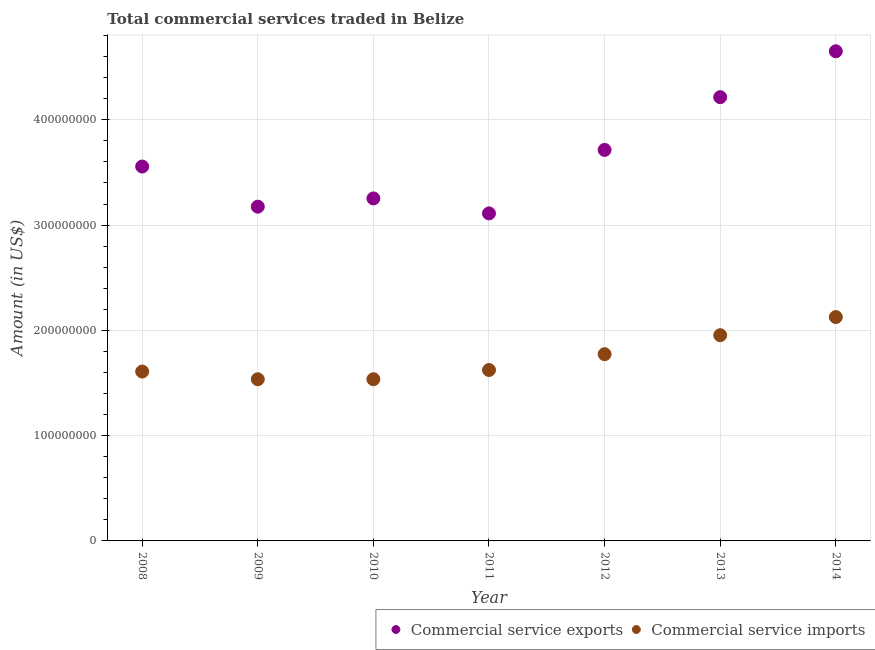How many different coloured dotlines are there?
Make the answer very short. 2. What is the amount of commercial service imports in 2010?
Make the answer very short. 1.54e+08. Across all years, what is the maximum amount of commercial service imports?
Your response must be concise. 2.13e+08. Across all years, what is the minimum amount of commercial service imports?
Make the answer very short. 1.54e+08. In which year was the amount of commercial service imports maximum?
Keep it short and to the point. 2014. What is the total amount of commercial service exports in the graph?
Make the answer very short. 2.57e+09. What is the difference between the amount of commercial service imports in 2008 and that in 2014?
Provide a succinct answer. -5.17e+07. What is the difference between the amount of commercial service exports in 2010 and the amount of commercial service imports in 2014?
Your answer should be very brief. 1.13e+08. What is the average amount of commercial service exports per year?
Make the answer very short. 3.67e+08. In the year 2011, what is the difference between the amount of commercial service exports and amount of commercial service imports?
Keep it short and to the point. 1.49e+08. In how many years, is the amount of commercial service imports greater than 280000000 US$?
Provide a succinct answer. 0. What is the ratio of the amount of commercial service imports in 2010 to that in 2014?
Your answer should be compact. 0.72. Is the amount of commercial service imports in 2008 less than that in 2014?
Ensure brevity in your answer.  Yes. What is the difference between the highest and the second highest amount of commercial service exports?
Provide a succinct answer. 4.36e+07. What is the difference between the highest and the lowest amount of commercial service imports?
Offer a terse response. 5.91e+07. In how many years, is the amount of commercial service imports greater than the average amount of commercial service imports taken over all years?
Offer a terse response. 3. Is the amount of commercial service imports strictly less than the amount of commercial service exports over the years?
Your answer should be compact. Yes. How many dotlines are there?
Ensure brevity in your answer.  2. How many years are there in the graph?
Provide a succinct answer. 7. What is the difference between two consecutive major ticks on the Y-axis?
Your answer should be very brief. 1.00e+08. Does the graph contain any zero values?
Ensure brevity in your answer.  No. Does the graph contain grids?
Your response must be concise. Yes. What is the title of the graph?
Make the answer very short. Total commercial services traded in Belize. Does "Current US$" appear as one of the legend labels in the graph?
Provide a short and direct response. No. What is the label or title of the X-axis?
Give a very brief answer. Year. What is the label or title of the Y-axis?
Offer a very short reply. Amount (in US$). What is the Amount (in US$) of Commercial service exports in 2008?
Offer a terse response. 3.56e+08. What is the Amount (in US$) in Commercial service imports in 2008?
Offer a terse response. 1.61e+08. What is the Amount (in US$) of Commercial service exports in 2009?
Give a very brief answer. 3.17e+08. What is the Amount (in US$) in Commercial service imports in 2009?
Give a very brief answer. 1.54e+08. What is the Amount (in US$) in Commercial service exports in 2010?
Your answer should be compact. 3.25e+08. What is the Amount (in US$) of Commercial service imports in 2010?
Your response must be concise. 1.54e+08. What is the Amount (in US$) in Commercial service exports in 2011?
Your answer should be very brief. 3.11e+08. What is the Amount (in US$) in Commercial service imports in 2011?
Give a very brief answer. 1.62e+08. What is the Amount (in US$) in Commercial service exports in 2012?
Your answer should be very brief. 3.71e+08. What is the Amount (in US$) of Commercial service imports in 2012?
Your answer should be very brief. 1.77e+08. What is the Amount (in US$) in Commercial service exports in 2013?
Your response must be concise. 4.21e+08. What is the Amount (in US$) of Commercial service imports in 2013?
Your answer should be compact. 1.95e+08. What is the Amount (in US$) of Commercial service exports in 2014?
Offer a very short reply. 4.65e+08. What is the Amount (in US$) of Commercial service imports in 2014?
Keep it short and to the point. 2.13e+08. Across all years, what is the maximum Amount (in US$) of Commercial service exports?
Your answer should be very brief. 4.65e+08. Across all years, what is the maximum Amount (in US$) of Commercial service imports?
Offer a very short reply. 2.13e+08. Across all years, what is the minimum Amount (in US$) of Commercial service exports?
Offer a terse response. 3.11e+08. Across all years, what is the minimum Amount (in US$) in Commercial service imports?
Provide a short and direct response. 1.54e+08. What is the total Amount (in US$) of Commercial service exports in the graph?
Keep it short and to the point. 2.57e+09. What is the total Amount (in US$) in Commercial service imports in the graph?
Your answer should be compact. 1.22e+09. What is the difference between the Amount (in US$) of Commercial service exports in 2008 and that in 2009?
Provide a succinct answer. 3.81e+07. What is the difference between the Amount (in US$) of Commercial service imports in 2008 and that in 2009?
Ensure brevity in your answer.  7.33e+06. What is the difference between the Amount (in US$) of Commercial service exports in 2008 and that in 2010?
Your answer should be compact. 3.03e+07. What is the difference between the Amount (in US$) in Commercial service imports in 2008 and that in 2010?
Give a very brief answer. 7.29e+06. What is the difference between the Amount (in US$) of Commercial service exports in 2008 and that in 2011?
Provide a short and direct response. 4.45e+07. What is the difference between the Amount (in US$) in Commercial service imports in 2008 and that in 2011?
Keep it short and to the point. -1.48e+06. What is the difference between the Amount (in US$) in Commercial service exports in 2008 and that in 2012?
Ensure brevity in your answer.  -1.58e+07. What is the difference between the Amount (in US$) in Commercial service imports in 2008 and that in 2012?
Provide a succinct answer. -1.65e+07. What is the difference between the Amount (in US$) in Commercial service exports in 2008 and that in 2013?
Give a very brief answer. -6.59e+07. What is the difference between the Amount (in US$) of Commercial service imports in 2008 and that in 2013?
Offer a terse response. -3.45e+07. What is the difference between the Amount (in US$) of Commercial service exports in 2008 and that in 2014?
Provide a short and direct response. -1.09e+08. What is the difference between the Amount (in US$) in Commercial service imports in 2008 and that in 2014?
Your response must be concise. -5.17e+07. What is the difference between the Amount (in US$) in Commercial service exports in 2009 and that in 2010?
Provide a short and direct response. -7.86e+06. What is the difference between the Amount (in US$) in Commercial service imports in 2009 and that in 2010?
Your answer should be very brief. -4.16e+04. What is the difference between the Amount (in US$) of Commercial service exports in 2009 and that in 2011?
Offer a terse response. 6.41e+06. What is the difference between the Amount (in US$) of Commercial service imports in 2009 and that in 2011?
Make the answer very short. -8.80e+06. What is the difference between the Amount (in US$) of Commercial service exports in 2009 and that in 2012?
Make the answer very short. -5.39e+07. What is the difference between the Amount (in US$) in Commercial service imports in 2009 and that in 2012?
Keep it short and to the point. -2.38e+07. What is the difference between the Amount (in US$) in Commercial service exports in 2009 and that in 2013?
Keep it short and to the point. -1.04e+08. What is the difference between the Amount (in US$) of Commercial service imports in 2009 and that in 2013?
Offer a terse response. -4.18e+07. What is the difference between the Amount (in US$) of Commercial service exports in 2009 and that in 2014?
Provide a succinct answer. -1.48e+08. What is the difference between the Amount (in US$) in Commercial service imports in 2009 and that in 2014?
Your answer should be very brief. -5.91e+07. What is the difference between the Amount (in US$) in Commercial service exports in 2010 and that in 2011?
Keep it short and to the point. 1.43e+07. What is the difference between the Amount (in US$) of Commercial service imports in 2010 and that in 2011?
Offer a terse response. -8.76e+06. What is the difference between the Amount (in US$) of Commercial service exports in 2010 and that in 2012?
Make the answer very short. -4.61e+07. What is the difference between the Amount (in US$) in Commercial service imports in 2010 and that in 2012?
Offer a terse response. -2.38e+07. What is the difference between the Amount (in US$) of Commercial service exports in 2010 and that in 2013?
Provide a short and direct response. -9.62e+07. What is the difference between the Amount (in US$) in Commercial service imports in 2010 and that in 2013?
Keep it short and to the point. -4.18e+07. What is the difference between the Amount (in US$) of Commercial service exports in 2010 and that in 2014?
Offer a very short reply. -1.40e+08. What is the difference between the Amount (in US$) of Commercial service imports in 2010 and that in 2014?
Make the answer very short. -5.90e+07. What is the difference between the Amount (in US$) in Commercial service exports in 2011 and that in 2012?
Make the answer very short. -6.03e+07. What is the difference between the Amount (in US$) in Commercial service imports in 2011 and that in 2012?
Keep it short and to the point. -1.50e+07. What is the difference between the Amount (in US$) of Commercial service exports in 2011 and that in 2013?
Provide a short and direct response. -1.10e+08. What is the difference between the Amount (in US$) of Commercial service imports in 2011 and that in 2013?
Offer a very short reply. -3.30e+07. What is the difference between the Amount (in US$) of Commercial service exports in 2011 and that in 2014?
Your answer should be compact. -1.54e+08. What is the difference between the Amount (in US$) in Commercial service imports in 2011 and that in 2014?
Make the answer very short. -5.03e+07. What is the difference between the Amount (in US$) of Commercial service exports in 2012 and that in 2013?
Make the answer very short. -5.01e+07. What is the difference between the Amount (in US$) of Commercial service imports in 2012 and that in 2013?
Offer a very short reply. -1.80e+07. What is the difference between the Amount (in US$) of Commercial service exports in 2012 and that in 2014?
Your answer should be compact. -9.37e+07. What is the difference between the Amount (in US$) in Commercial service imports in 2012 and that in 2014?
Offer a terse response. -3.53e+07. What is the difference between the Amount (in US$) in Commercial service exports in 2013 and that in 2014?
Give a very brief answer. -4.36e+07. What is the difference between the Amount (in US$) of Commercial service imports in 2013 and that in 2014?
Provide a short and direct response. -1.72e+07. What is the difference between the Amount (in US$) of Commercial service exports in 2008 and the Amount (in US$) of Commercial service imports in 2009?
Provide a succinct answer. 2.02e+08. What is the difference between the Amount (in US$) in Commercial service exports in 2008 and the Amount (in US$) in Commercial service imports in 2010?
Provide a short and direct response. 2.02e+08. What is the difference between the Amount (in US$) of Commercial service exports in 2008 and the Amount (in US$) of Commercial service imports in 2011?
Your response must be concise. 1.93e+08. What is the difference between the Amount (in US$) of Commercial service exports in 2008 and the Amount (in US$) of Commercial service imports in 2012?
Provide a short and direct response. 1.78e+08. What is the difference between the Amount (in US$) of Commercial service exports in 2008 and the Amount (in US$) of Commercial service imports in 2013?
Your answer should be very brief. 1.60e+08. What is the difference between the Amount (in US$) in Commercial service exports in 2008 and the Amount (in US$) in Commercial service imports in 2014?
Provide a succinct answer. 1.43e+08. What is the difference between the Amount (in US$) in Commercial service exports in 2009 and the Amount (in US$) in Commercial service imports in 2010?
Offer a terse response. 1.64e+08. What is the difference between the Amount (in US$) of Commercial service exports in 2009 and the Amount (in US$) of Commercial service imports in 2011?
Ensure brevity in your answer.  1.55e+08. What is the difference between the Amount (in US$) of Commercial service exports in 2009 and the Amount (in US$) of Commercial service imports in 2012?
Offer a very short reply. 1.40e+08. What is the difference between the Amount (in US$) of Commercial service exports in 2009 and the Amount (in US$) of Commercial service imports in 2013?
Provide a succinct answer. 1.22e+08. What is the difference between the Amount (in US$) of Commercial service exports in 2009 and the Amount (in US$) of Commercial service imports in 2014?
Provide a succinct answer. 1.05e+08. What is the difference between the Amount (in US$) of Commercial service exports in 2010 and the Amount (in US$) of Commercial service imports in 2011?
Ensure brevity in your answer.  1.63e+08. What is the difference between the Amount (in US$) in Commercial service exports in 2010 and the Amount (in US$) in Commercial service imports in 2012?
Your answer should be very brief. 1.48e+08. What is the difference between the Amount (in US$) of Commercial service exports in 2010 and the Amount (in US$) of Commercial service imports in 2013?
Give a very brief answer. 1.30e+08. What is the difference between the Amount (in US$) in Commercial service exports in 2010 and the Amount (in US$) in Commercial service imports in 2014?
Provide a succinct answer. 1.13e+08. What is the difference between the Amount (in US$) of Commercial service exports in 2011 and the Amount (in US$) of Commercial service imports in 2012?
Provide a short and direct response. 1.34e+08. What is the difference between the Amount (in US$) in Commercial service exports in 2011 and the Amount (in US$) in Commercial service imports in 2013?
Provide a succinct answer. 1.16e+08. What is the difference between the Amount (in US$) in Commercial service exports in 2011 and the Amount (in US$) in Commercial service imports in 2014?
Ensure brevity in your answer.  9.84e+07. What is the difference between the Amount (in US$) of Commercial service exports in 2012 and the Amount (in US$) of Commercial service imports in 2013?
Provide a succinct answer. 1.76e+08. What is the difference between the Amount (in US$) of Commercial service exports in 2012 and the Amount (in US$) of Commercial service imports in 2014?
Keep it short and to the point. 1.59e+08. What is the difference between the Amount (in US$) of Commercial service exports in 2013 and the Amount (in US$) of Commercial service imports in 2014?
Your answer should be compact. 2.09e+08. What is the average Amount (in US$) in Commercial service exports per year?
Ensure brevity in your answer.  3.67e+08. What is the average Amount (in US$) of Commercial service imports per year?
Provide a short and direct response. 1.74e+08. In the year 2008, what is the difference between the Amount (in US$) in Commercial service exports and Amount (in US$) in Commercial service imports?
Offer a terse response. 1.95e+08. In the year 2009, what is the difference between the Amount (in US$) of Commercial service exports and Amount (in US$) of Commercial service imports?
Provide a succinct answer. 1.64e+08. In the year 2010, what is the difference between the Amount (in US$) in Commercial service exports and Amount (in US$) in Commercial service imports?
Offer a terse response. 1.72e+08. In the year 2011, what is the difference between the Amount (in US$) in Commercial service exports and Amount (in US$) in Commercial service imports?
Provide a succinct answer. 1.49e+08. In the year 2012, what is the difference between the Amount (in US$) in Commercial service exports and Amount (in US$) in Commercial service imports?
Your answer should be very brief. 1.94e+08. In the year 2013, what is the difference between the Amount (in US$) of Commercial service exports and Amount (in US$) of Commercial service imports?
Give a very brief answer. 2.26e+08. In the year 2014, what is the difference between the Amount (in US$) of Commercial service exports and Amount (in US$) of Commercial service imports?
Your answer should be compact. 2.52e+08. What is the ratio of the Amount (in US$) of Commercial service exports in 2008 to that in 2009?
Your answer should be very brief. 1.12. What is the ratio of the Amount (in US$) in Commercial service imports in 2008 to that in 2009?
Ensure brevity in your answer.  1.05. What is the ratio of the Amount (in US$) of Commercial service exports in 2008 to that in 2010?
Make the answer very short. 1.09. What is the ratio of the Amount (in US$) in Commercial service imports in 2008 to that in 2010?
Make the answer very short. 1.05. What is the ratio of the Amount (in US$) of Commercial service exports in 2008 to that in 2011?
Your answer should be very brief. 1.14. What is the ratio of the Amount (in US$) of Commercial service imports in 2008 to that in 2011?
Provide a succinct answer. 0.99. What is the ratio of the Amount (in US$) in Commercial service exports in 2008 to that in 2012?
Offer a terse response. 0.96. What is the ratio of the Amount (in US$) in Commercial service imports in 2008 to that in 2012?
Make the answer very short. 0.91. What is the ratio of the Amount (in US$) of Commercial service exports in 2008 to that in 2013?
Ensure brevity in your answer.  0.84. What is the ratio of the Amount (in US$) of Commercial service imports in 2008 to that in 2013?
Make the answer very short. 0.82. What is the ratio of the Amount (in US$) in Commercial service exports in 2008 to that in 2014?
Your response must be concise. 0.76. What is the ratio of the Amount (in US$) in Commercial service imports in 2008 to that in 2014?
Give a very brief answer. 0.76. What is the ratio of the Amount (in US$) in Commercial service exports in 2009 to that in 2010?
Your response must be concise. 0.98. What is the ratio of the Amount (in US$) of Commercial service imports in 2009 to that in 2010?
Your response must be concise. 1. What is the ratio of the Amount (in US$) of Commercial service exports in 2009 to that in 2011?
Provide a short and direct response. 1.02. What is the ratio of the Amount (in US$) in Commercial service imports in 2009 to that in 2011?
Make the answer very short. 0.95. What is the ratio of the Amount (in US$) of Commercial service exports in 2009 to that in 2012?
Give a very brief answer. 0.85. What is the ratio of the Amount (in US$) in Commercial service imports in 2009 to that in 2012?
Your answer should be very brief. 0.87. What is the ratio of the Amount (in US$) in Commercial service exports in 2009 to that in 2013?
Give a very brief answer. 0.75. What is the ratio of the Amount (in US$) in Commercial service imports in 2009 to that in 2013?
Give a very brief answer. 0.79. What is the ratio of the Amount (in US$) in Commercial service exports in 2009 to that in 2014?
Give a very brief answer. 0.68. What is the ratio of the Amount (in US$) of Commercial service imports in 2009 to that in 2014?
Offer a terse response. 0.72. What is the ratio of the Amount (in US$) of Commercial service exports in 2010 to that in 2011?
Keep it short and to the point. 1.05. What is the ratio of the Amount (in US$) in Commercial service imports in 2010 to that in 2011?
Provide a short and direct response. 0.95. What is the ratio of the Amount (in US$) in Commercial service exports in 2010 to that in 2012?
Make the answer very short. 0.88. What is the ratio of the Amount (in US$) in Commercial service imports in 2010 to that in 2012?
Your response must be concise. 0.87. What is the ratio of the Amount (in US$) of Commercial service exports in 2010 to that in 2013?
Offer a terse response. 0.77. What is the ratio of the Amount (in US$) of Commercial service imports in 2010 to that in 2013?
Give a very brief answer. 0.79. What is the ratio of the Amount (in US$) in Commercial service exports in 2010 to that in 2014?
Keep it short and to the point. 0.7. What is the ratio of the Amount (in US$) of Commercial service imports in 2010 to that in 2014?
Your answer should be very brief. 0.72. What is the ratio of the Amount (in US$) of Commercial service exports in 2011 to that in 2012?
Provide a succinct answer. 0.84. What is the ratio of the Amount (in US$) of Commercial service imports in 2011 to that in 2012?
Provide a short and direct response. 0.92. What is the ratio of the Amount (in US$) in Commercial service exports in 2011 to that in 2013?
Offer a terse response. 0.74. What is the ratio of the Amount (in US$) of Commercial service imports in 2011 to that in 2013?
Provide a succinct answer. 0.83. What is the ratio of the Amount (in US$) in Commercial service exports in 2011 to that in 2014?
Offer a very short reply. 0.67. What is the ratio of the Amount (in US$) of Commercial service imports in 2011 to that in 2014?
Provide a short and direct response. 0.76. What is the ratio of the Amount (in US$) in Commercial service exports in 2012 to that in 2013?
Ensure brevity in your answer.  0.88. What is the ratio of the Amount (in US$) of Commercial service imports in 2012 to that in 2013?
Provide a short and direct response. 0.91. What is the ratio of the Amount (in US$) in Commercial service exports in 2012 to that in 2014?
Offer a terse response. 0.8. What is the ratio of the Amount (in US$) in Commercial service imports in 2012 to that in 2014?
Your answer should be very brief. 0.83. What is the ratio of the Amount (in US$) of Commercial service exports in 2013 to that in 2014?
Offer a terse response. 0.91. What is the ratio of the Amount (in US$) of Commercial service imports in 2013 to that in 2014?
Your answer should be compact. 0.92. What is the difference between the highest and the second highest Amount (in US$) in Commercial service exports?
Ensure brevity in your answer.  4.36e+07. What is the difference between the highest and the second highest Amount (in US$) of Commercial service imports?
Provide a succinct answer. 1.72e+07. What is the difference between the highest and the lowest Amount (in US$) of Commercial service exports?
Make the answer very short. 1.54e+08. What is the difference between the highest and the lowest Amount (in US$) of Commercial service imports?
Your answer should be very brief. 5.91e+07. 